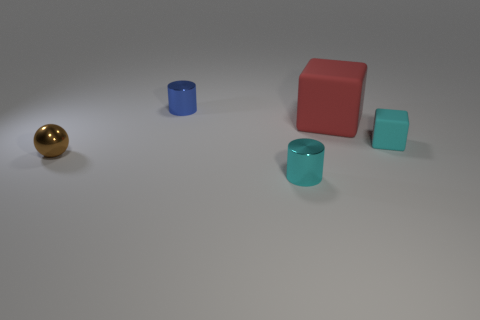Is there any other thing that has the same size as the red matte thing?
Provide a short and direct response. No. There is a tiny object in front of the tiny shiny sphere; is its color the same as the tiny matte cube?
Offer a very short reply. Yes. What number of blue objects are either tiny things or tiny rubber cubes?
Give a very brief answer. 1. What is the color of the small shiny object that is behind the small metal thing that is on the left side of the blue cylinder?
Your response must be concise. Blue. What is the material of the thing that is the same color as the small block?
Your response must be concise. Metal. There is a metal object that is in front of the tiny brown shiny sphere; what color is it?
Make the answer very short. Cyan. There is a cylinder that is in front of the metal sphere; is its size the same as the big red block?
Offer a terse response. No. There is a metal thing that is the same color as the small rubber block; what is its size?
Your response must be concise. Small. Are there any cyan rubber cubes that have the same size as the blue metal thing?
Offer a very short reply. Yes. There is a small cylinder that is in front of the small matte thing; is it the same color as the small object that is right of the cyan cylinder?
Provide a short and direct response. Yes. 